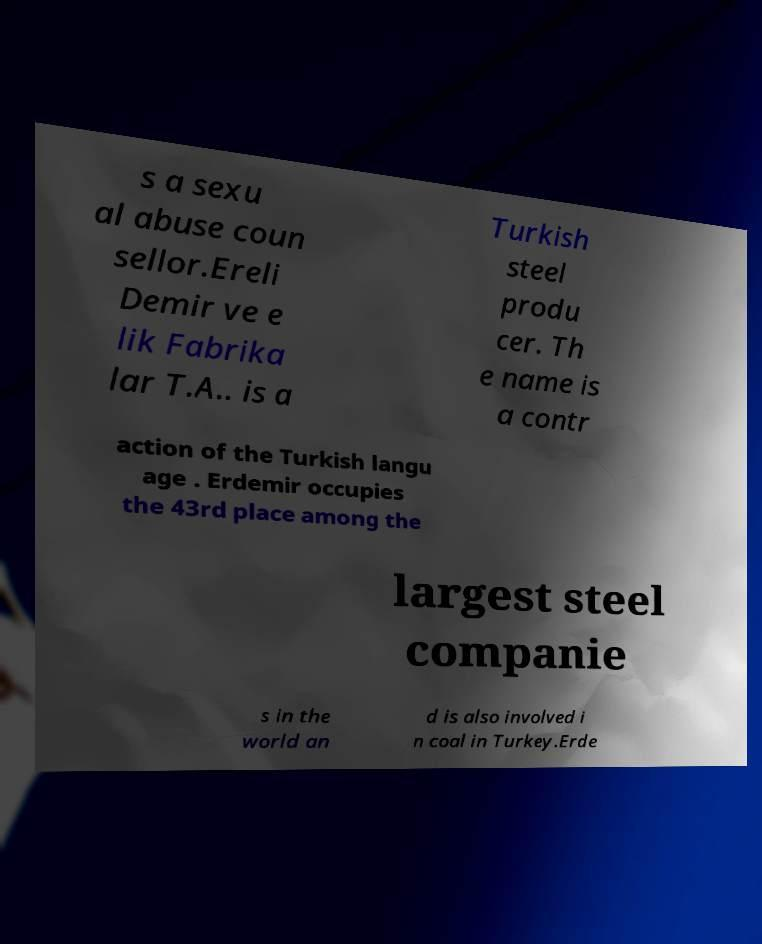Could you assist in decoding the text presented in this image and type it out clearly? s a sexu al abuse coun sellor.Ereli Demir ve e lik Fabrika lar T.A.. is a Turkish steel produ cer. Th e name is a contr action of the Turkish langu age . Erdemir occupies the 43rd place among the largest steel companie s in the world an d is also involved i n coal in Turkey.Erde 